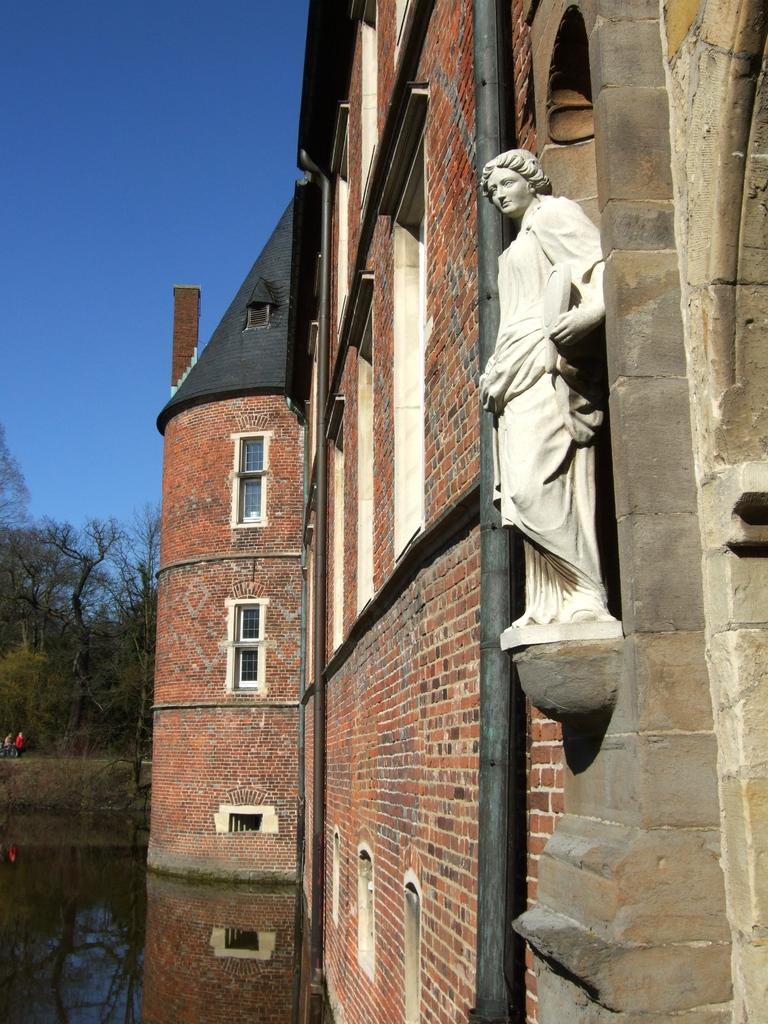What is the primary element visible in the image? There is water in the image. Are there any living beings present in the image? Yes, there are people in the image. What type of natural elements can be seen in the image? There are trees in the image. What type of structure is present in the image? There is a building in the image. Can you describe any other objects or features in the image? There is a statue, windows, a brick wall, and pipes visible in the image. What is the color of the sky in the image? The sky is blue in the image. What type of oil can be seen dripping from the statue in the image? There is no oil present in the image, and the statue does not appear to be dripping anything. 